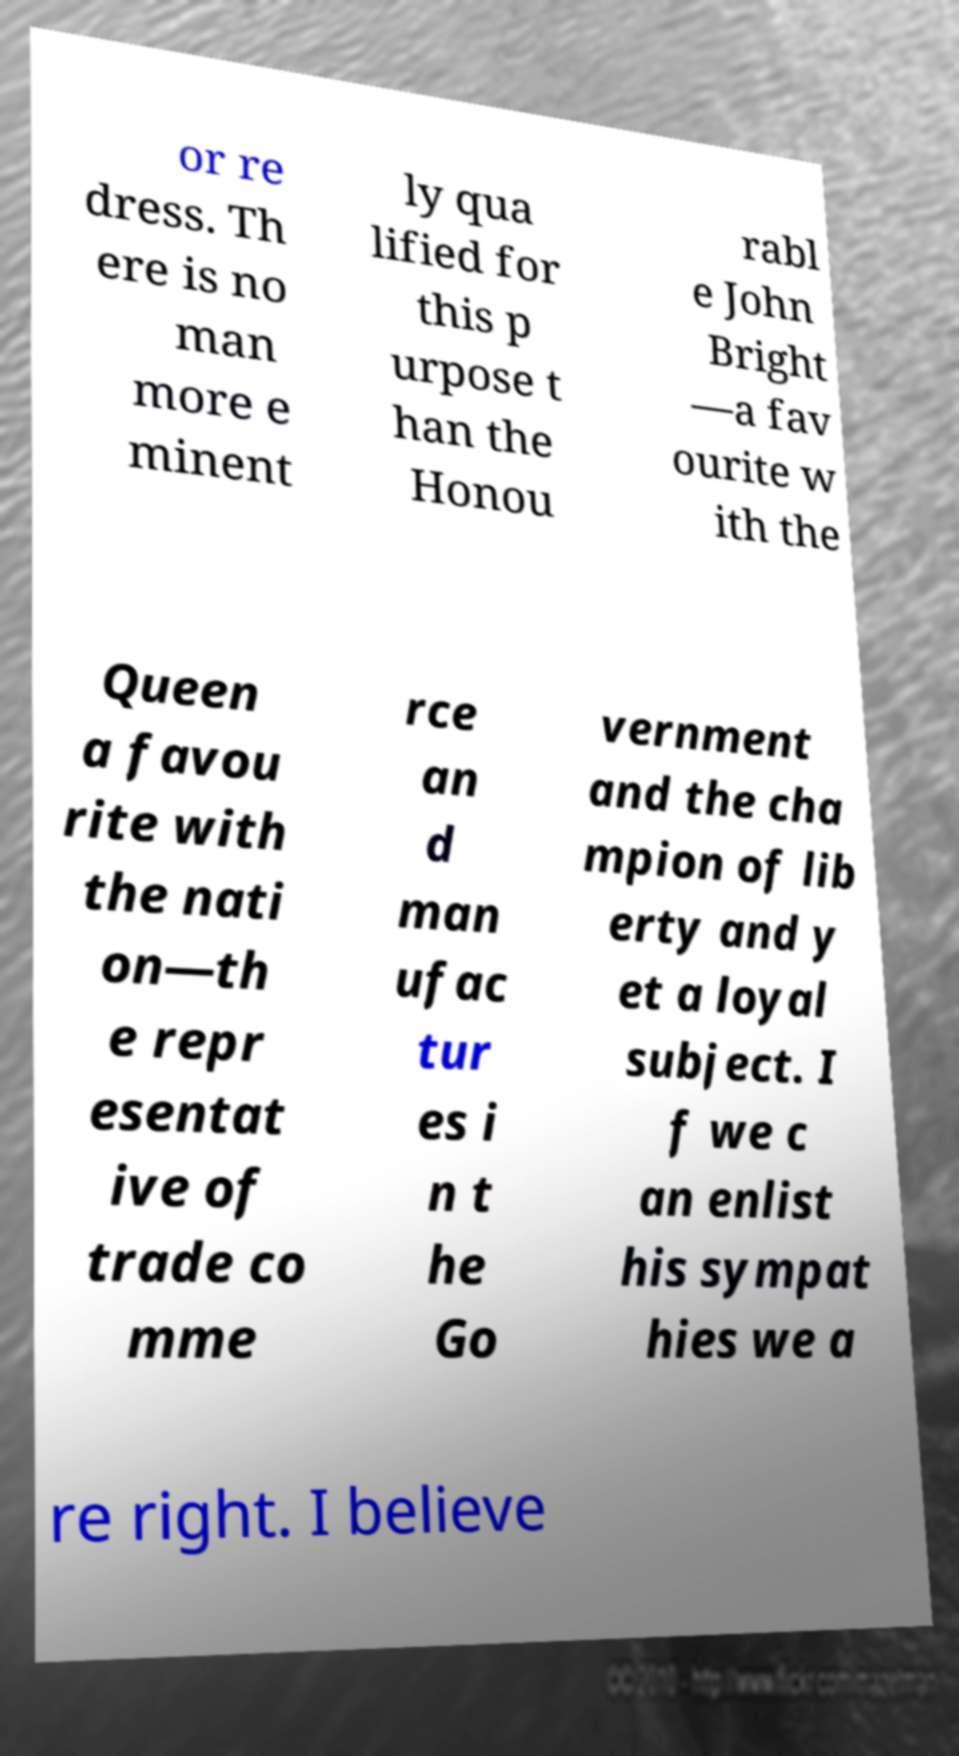For documentation purposes, I need the text within this image transcribed. Could you provide that? or re dress. Th ere is no man more e minent ly qua lified for this p urpose t han the Honou rabl e John Bright —a fav ourite w ith the Queen a favou rite with the nati on—th e repr esentat ive of trade co mme rce an d man ufac tur es i n t he Go vernment and the cha mpion of lib erty and y et a loyal subject. I f we c an enlist his sympat hies we a re right. I believe 